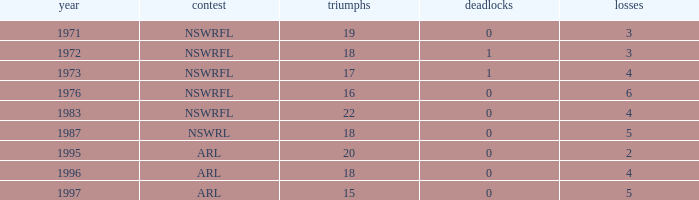What highest Year has Wins 15 and Losses less than 5? None. 